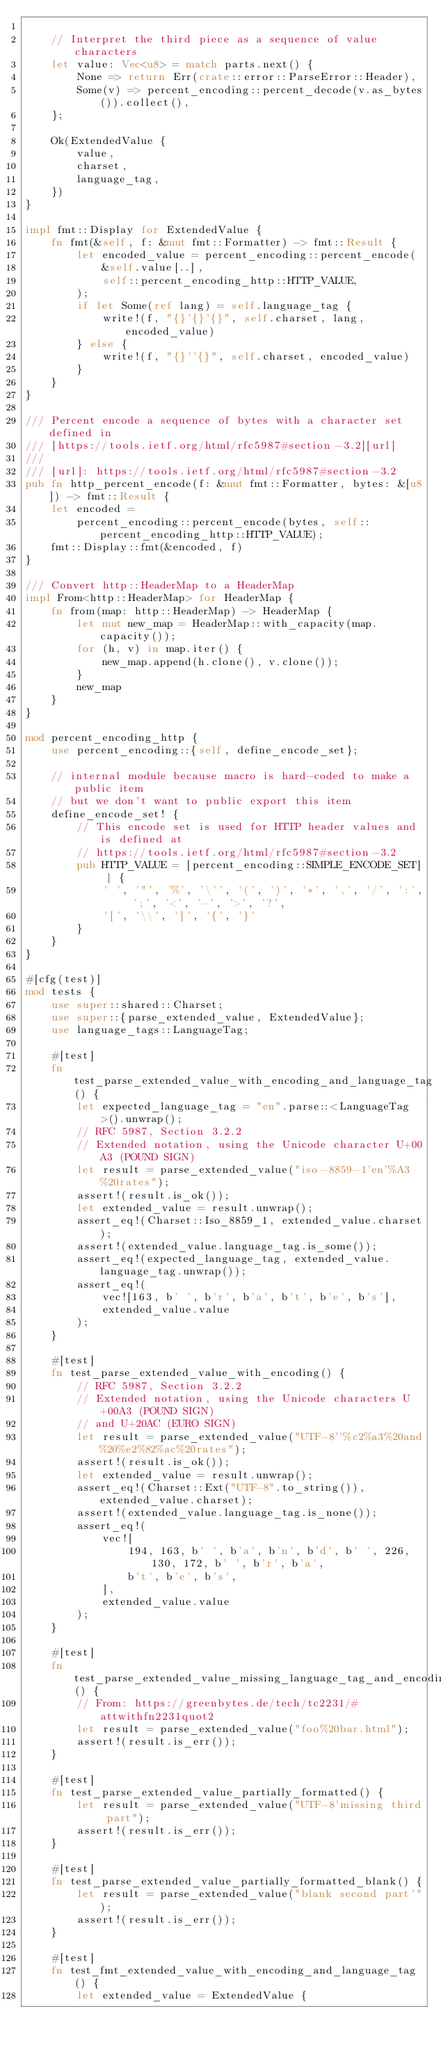<code> <loc_0><loc_0><loc_500><loc_500><_Rust_>
    // Interpret the third piece as a sequence of value characters
    let value: Vec<u8> = match parts.next() {
        None => return Err(crate::error::ParseError::Header),
        Some(v) => percent_encoding::percent_decode(v.as_bytes()).collect(),
    };

    Ok(ExtendedValue {
        value,
        charset,
        language_tag,
    })
}

impl fmt::Display for ExtendedValue {
    fn fmt(&self, f: &mut fmt::Formatter) -> fmt::Result {
        let encoded_value = percent_encoding::percent_encode(
            &self.value[..],
            self::percent_encoding_http::HTTP_VALUE,
        );
        if let Some(ref lang) = self.language_tag {
            write!(f, "{}'{}'{}", self.charset, lang, encoded_value)
        } else {
            write!(f, "{}''{}", self.charset, encoded_value)
        }
    }
}

/// Percent encode a sequence of bytes with a character set defined in
/// [https://tools.ietf.org/html/rfc5987#section-3.2][url]
///
/// [url]: https://tools.ietf.org/html/rfc5987#section-3.2
pub fn http_percent_encode(f: &mut fmt::Formatter, bytes: &[u8]) -> fmt::Result {
    let encoded =
        percent_encoding::percent_encode(bytes, self::percent_encoding_http::HTTP_VALUE);
    fmt::Display::fmt(&encoded, f)
}

/// Convert http::HeaderMap to a HeaderMap
impl From<http::HeaderMap> for HeaderMap {
    fn from(map: http::HeaderMap) -> HeaderMap {
        let mut new_map = HeaderMap::with_capacity(map.capacity());
        for (h, v) in map.iter() {
            new_map.append(h.clone(), v.clone());
        }
        new_map
    }
}

mod percent_encoding_http {
    use percent_encoding::{self, define_encode_set};

    // internal module because macro is hard-coded to make a public item
    // but we don't want to public export this item
    define_encode_set! {
        // This encode set is used for HTTP header values and is defined at
        // https://tools.ietf.org/html/rfc5987#section-3.2
        pub HTTP_VALUE = [percent_encoding::SIMPLE_ENCODE_SET] | {
            ' ', '"', '%', '\'', '(', ')', '*', ',', '/', ':', ';', '<', '-', '>', '?',
            '[', '\\', ']', '{', '}'
        }
    }
}

#[cfg(test)]
mod tests {
    use super::shared::Charset;
    use super::{parse_extended_value, ExtendedValue};
    use language_tags::LanguageTag;

    #[test]
    fn test_parse_extended_value_with_encoding_and_language_tag() {
        let expected_language_tag = "en".parse::<LanguageTag>().unwrap();
        // RFC 5987, Section 3.2.2
        // Extended notation, using the Unicode character U+00A3 (POUND SIGN)
        let result = parse_extended_value("iso-8859-1'en'%A3%20rates");
        assert!(result.is_ok());
        let extended_value = result.unwrap();
        assert_eq!(Charset::Iso_8859_1, extended_value.charset);
        assert!(extended_value.language_tag.is_some());
        assert_eq!(expected_language_tag, extended_value.language_tag.unwrap());
        assert_eq!(
            vec![163, b' ', b'r', b'a', b't', b'e', b's'],
            extended_value.value
        );
    }

    #[test]
    fn test_parse_extended_value_with_encoding() {
        // RFC 5987, Section 3.2.2
        // Extended notation, using the Unicode characters U+00A3 (POUND SIGN)
        // and U+20AC (EURO SIGN)
        let result = parse_extended_value("UTF-8''%c2%a3%20and%20%e2%82%ac%20rates");
        assert!(result.is_ok());
        let extended_value = result.unwrap();
        assert_eq!(Charset::Ext("UTF-8".to_string()), extended_value.charset);
        assert!(extended_value.language_tag.is_none());
        assert_eq!(
            vec![
                194, 163, b' ', b'a', b'n', b'd', b' ', 226, 130, 172, b' ', b'r', b'a',
                b't', b'e', b's',
            ],
            extended_value.value
        );
    }

    #[test]
    fn test_parse_extended_value_missing_language_tag_and_encoding() {
        // From: https://greenbytes.de/tech/tc2231/#attwithfn2231quot2
        let result = parse_extended_value("foo%20bar.html");
        assert!(result.is_err());
    }

    #[test]
    fn test_parse_extended_value_partially_formatted() {
        let result = parse_extended_value("UTF-8'missing third part");
        assert!(result.is_err());
    }

    #[test]
    fn test_parse_extended_value_partially_formatted_blank() {
        let result = parse_extended_value("blank second part'");
        assert!(result.is_err());
    }

    #[test]
    fn test_fmt_extended_value_with_encoding_and_language_tag() {
        let extended_value = ExtendedValue {</code> 